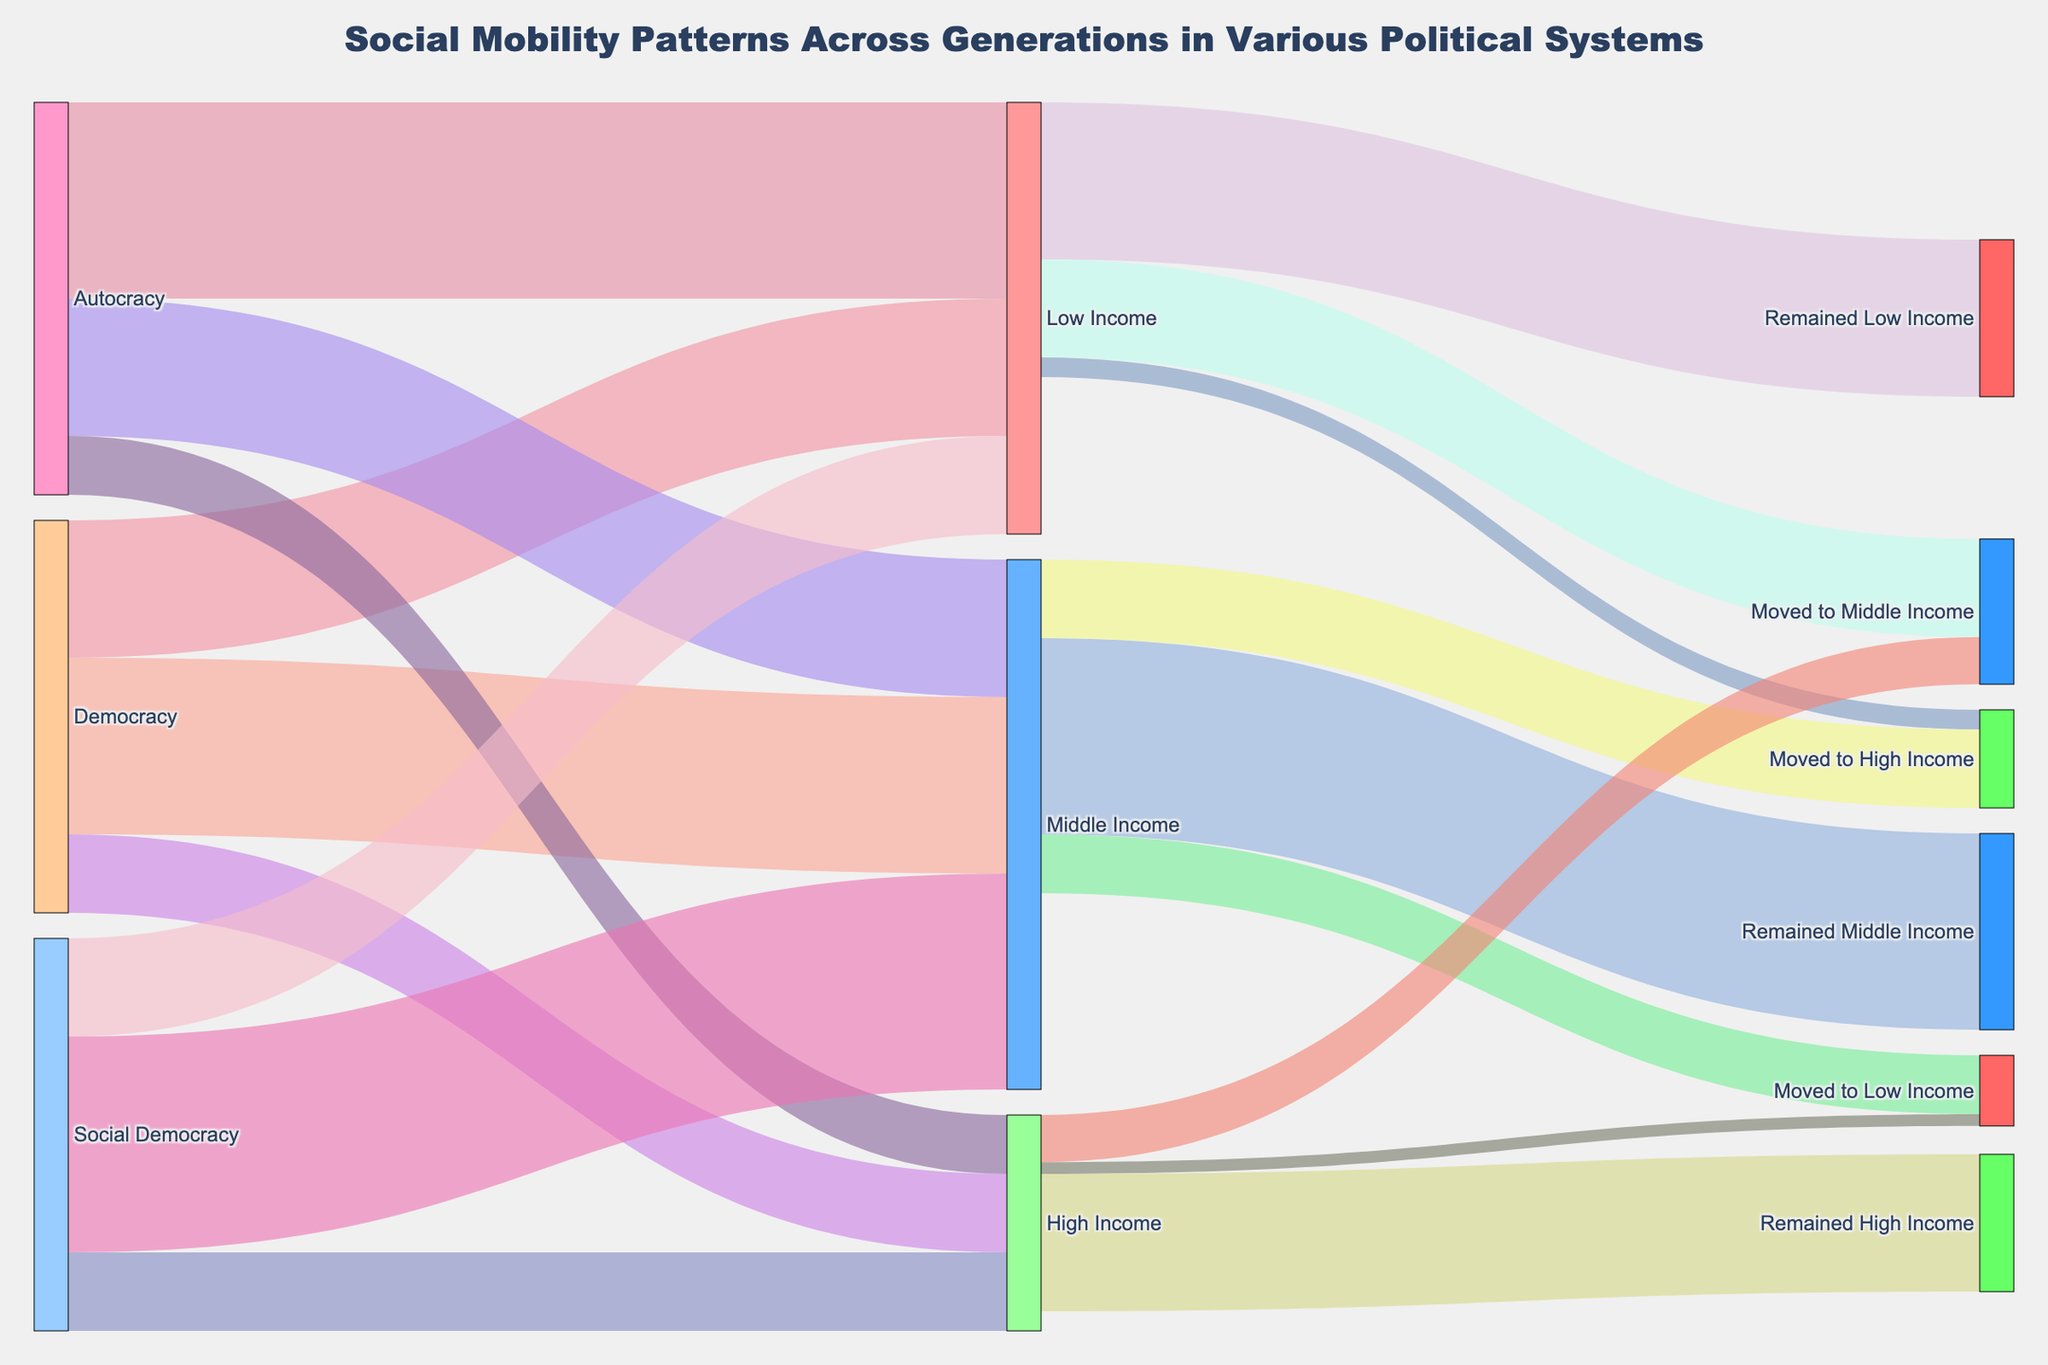What political systems are represented in the diagram? The diagram visually differentiates segments representing Democracy, Autocracy, and Social Democracy, each shown with distinct connections to income categories.
Answer: Democracy, Autocracy, Social Democracy Which income category has the highest proportion of people remaining in the same income bracket in the next generation? By observing the widths of the flows, the Middle Income category has the thickest band connecting to 'Remained Middle Income', indicating the highest proportion.
Answer: Middle Income How many people from Low Income move to High Income? The diagram shows a flow from Low Income to High Income labeled with a value of 5. This means 5 people move from Low Income to High Income.
Answer: 5 What is the total number of people in the High Income category under Autocracy? Sum of transitions flowing out from Autocracy to Low Income (50), Middle Income (35), and High Income (15). The total is 50 + 35 + 15 = 100.
Answer: 100 Compare the percentage of people moving from Middle to High Income between Democracy and Social Democracy. Under Democracy: 20/(35+45+20) = 20%; under Social Democracy: 20/(25+55+20) = 18%, comparing these shows Democracy has a higher percentage.
Answer: Democracy has a higher percentage Which income category has the least social mobility, and why? 'High Income' has the least social mobility due to the fewest and narrowest outgoing flows. Most people in this category remain in High Income.
Answer: High Income How does the movement from Low Income to Middle Income compare across different political systems? By examining flow widths and labels connected to 'Moved to Middle Income', we see Democracy (25), Autocracy (15), and Social Democracy (55), showing significant variation.
Answer: Social Democracy has the highest movement, followed by Democracy and then Autocracy What is the total number of people moving from Middle Income to other categories? Summing flows: Middle to Low (15), Middle to High (20). Total is 15 + 20 = 35
Answer: 35 What percentage of people remain in the Middle Income category under Social Democracy? Calculate: outflow from Social Democracy (55). Total people in category: 25+55+20=100. Therefore, percentage is 55/100 = 55%.
Answer: 55% Which political system has the most significant upward mobility from Low to High Income? Comparing values, Democracy (5), Autocracy (0), Social Democracy (5). Both Democracy and Social Democracy have the highest equal upward mobility.
Answer: Democracy and Social Democracy 